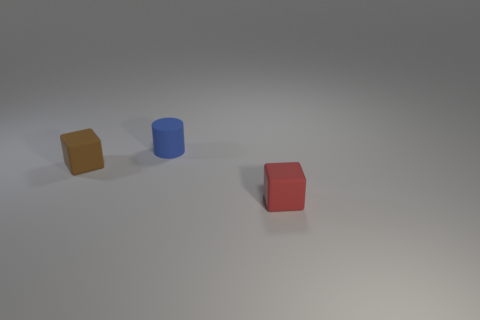Is there another small thing made of the same material as the brown thing?
Provide a short and direct response. Yes. The small brown rubber thing is what shape?
Give a very brief answer. Cube. What is the color of the small block that is made of the same material as the red thing?
Your response must be concise. Brown. How many brown objects are rubber cylinders or matte objects?
Offer a very short reply. 1. Is the number of brown matte things greater than the number of blocks?
Ensure brevity in your answer.  No. What number of things are rubber objects that are on the left side of the matte cylinder or things behind the red cube?
Ensure brevity in your answer.  2. There is a cylinder that is the same size as the brown matte block; what color is it?
Your answer should be compact. Blue. Are the brown thing and the red thing made of the same material?
Ensure brevity in your answer.  Yes. There is a small cube that is in front of the small block that is behind the red rubber thing; what is it made of?
Make the answer very short. Rubber. Are there more small blue cylinders that are right of the tiny red matte block than small blue shiny things?
Provide a short and direct response. No. 